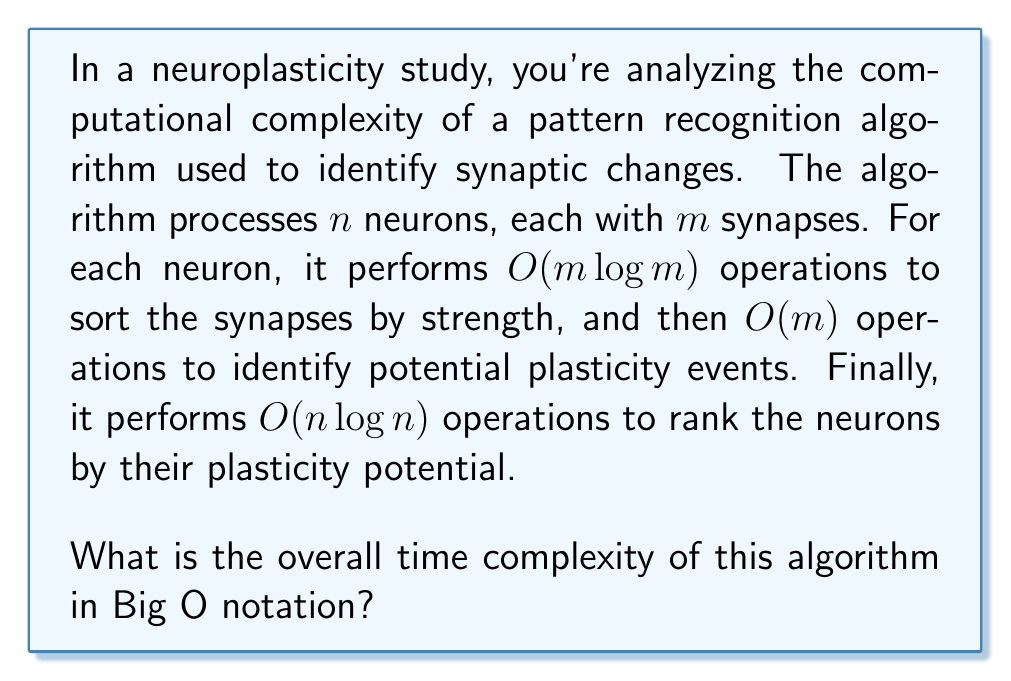Help me with this question. Let's break down the algorithm's steps and analyze their complexities:

1. For each of the $n$ neurons:
   a. Sort $m$ synapses: $O(m \log m)$
   b. Identify plasticity events: $O(m)$
   
   The total operations per neuron: $O(m \log m + m) = O(m \log m)$

2. This is done for all $n$ neurons, so the total complexity for step 1 is:
   $O(n \cdot m \log m)$

3. Finally, ranking $n$ neurons: $O(n \log n)$

To determine the overall complexity, we add these components:

$O(n \cdot m \log m + n \log n)$

We can simplify this by considering the dominant term. Since $m$ is typically much larger than $n$ in neuronal networks (each neuron has many synapses), the $n \cdot m \log m$ term will dominate.

Therefore, the overall time complexity is $O(n \cdot m \log m)$.
Answer: $O(n \cdot m \log m)$ 